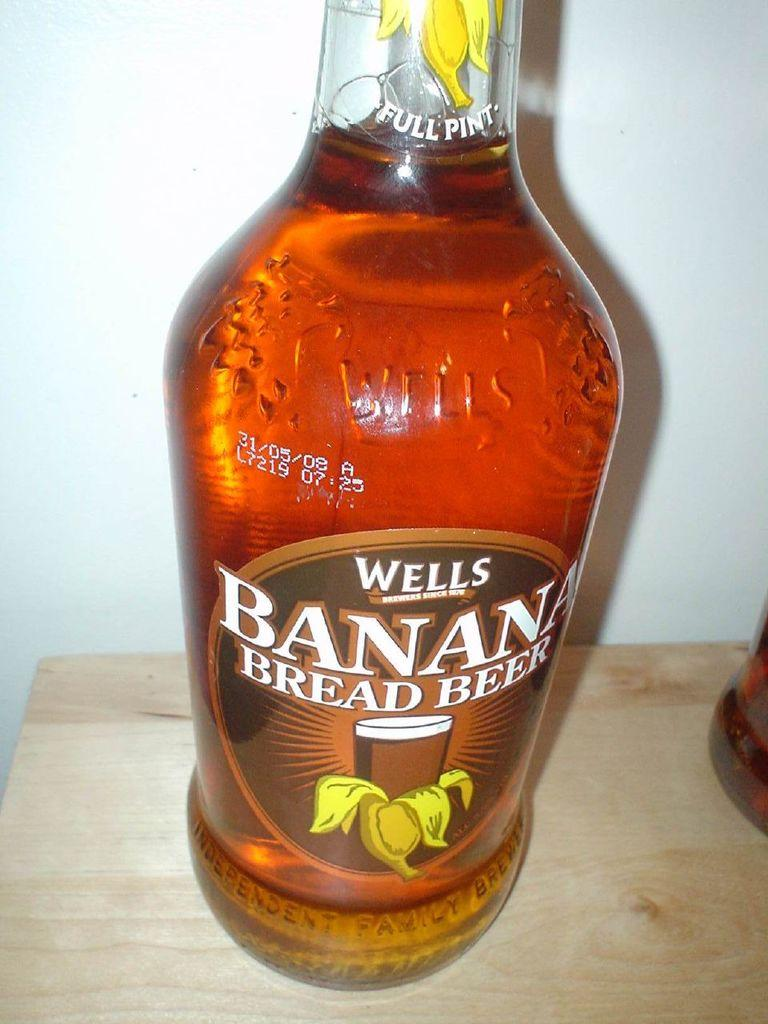Provide a one-sentence caption for the provided image. a close up of Wells Banana Bread Beer Full Pint. 